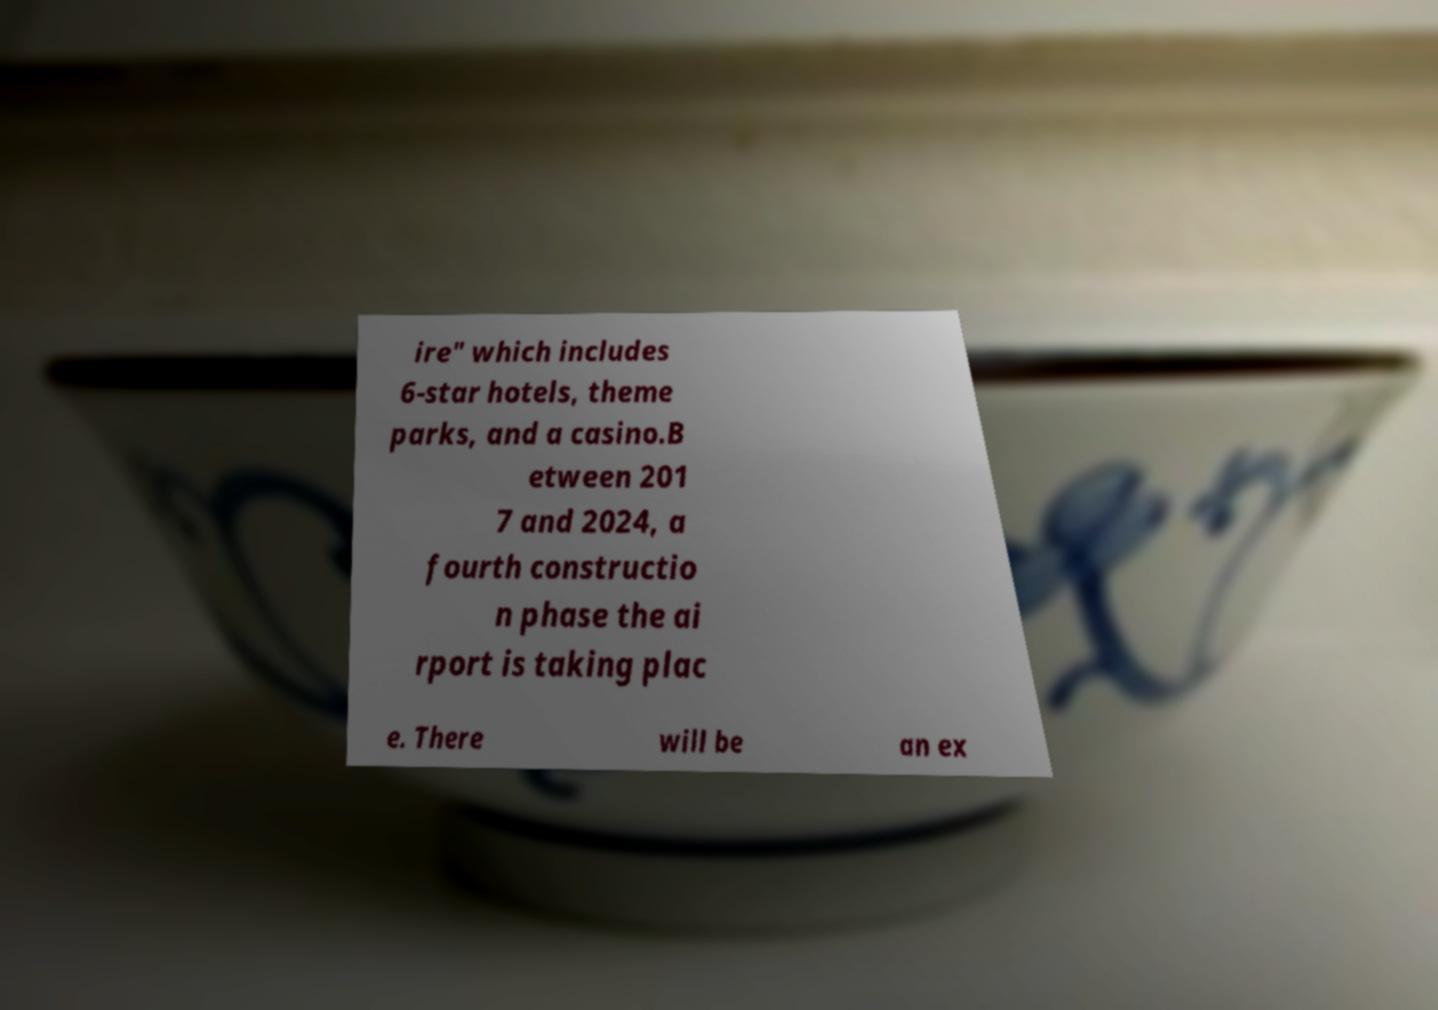Can you read and provide the text displayed in the image?This photo seems to have some interesting text. Can you extract and type it out for me? ire" which includes 6-star hotels, theme parks, and a casino.B etween 201 7 and 2024, a fourth constructio n phase the ai rport is taking plac e. There will be an ex 